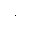<formula> <loc_0><loc_0><loc_500><loc_500>\cdot</formula> 